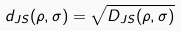Convert formula to latex. <formula><loc_0><loc_0><loc_500><loc_500>d _ { J S } ( \rho , \sigma ) = \sqrt { D _ { J S } ( \rho , \sigma ) }</formula> 